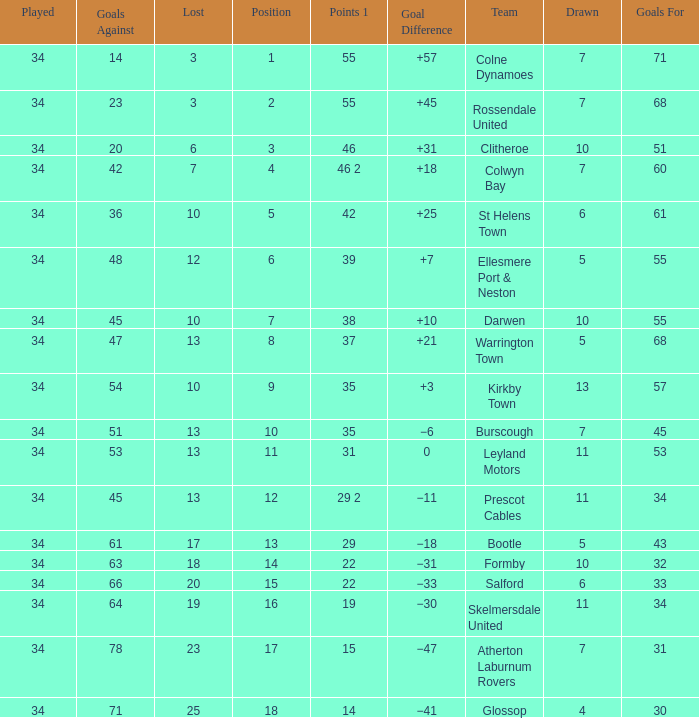Which Goals For has a Played larger than 34? None. 